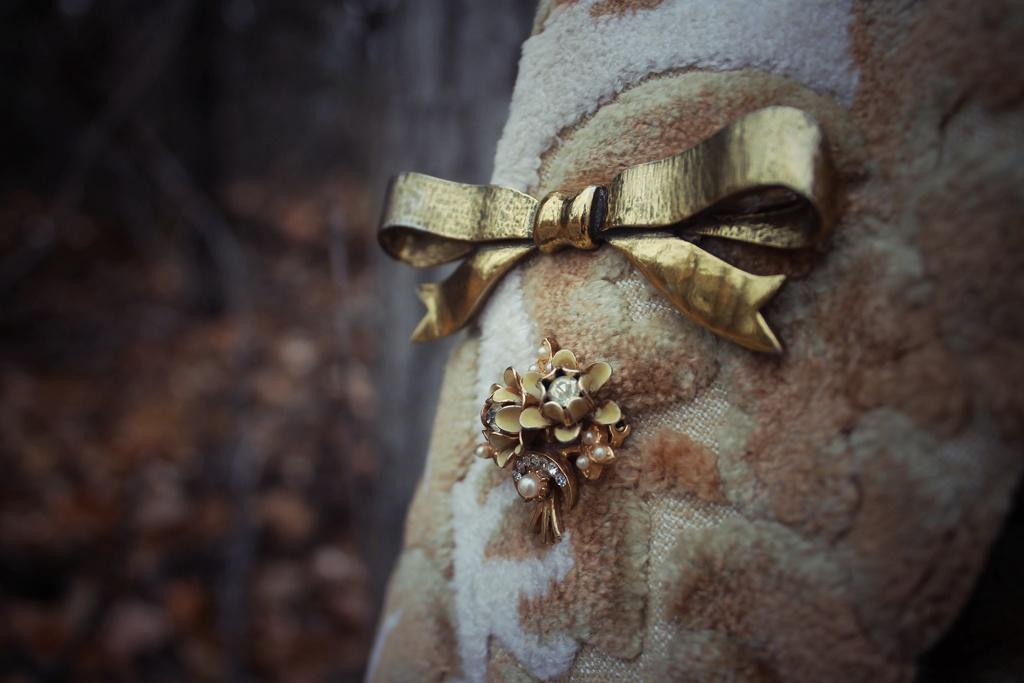What can be seen in the image that adds visual interest? There are decorations in the image. Where are the decorations located? The decorations are placed on a cloth. What type of neck decoration is visible in the image? There is no neck decoration present in the image. 